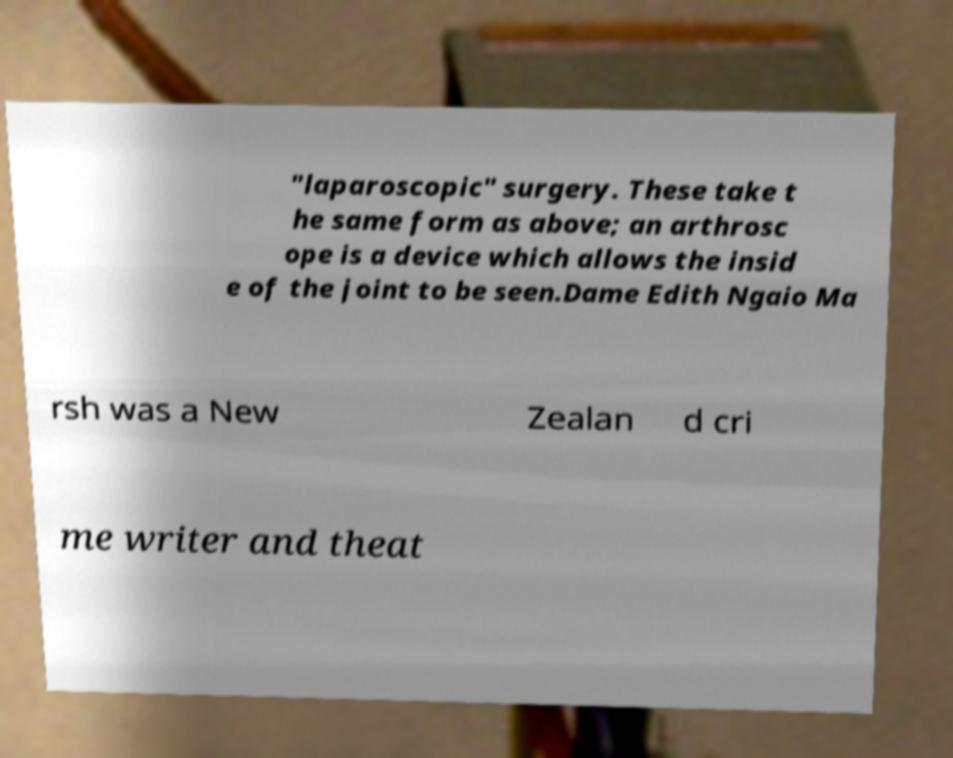What messages or text are displayed in this image? I need them in a readable, typed format. "laparoscopic" surgery. These take t he same form as above; an arthrosc ope is a device which allows the insid e of the joint to be seen.Dame Edith Ngaio Ma rsh was a New Zealan d cri me writer and theat 